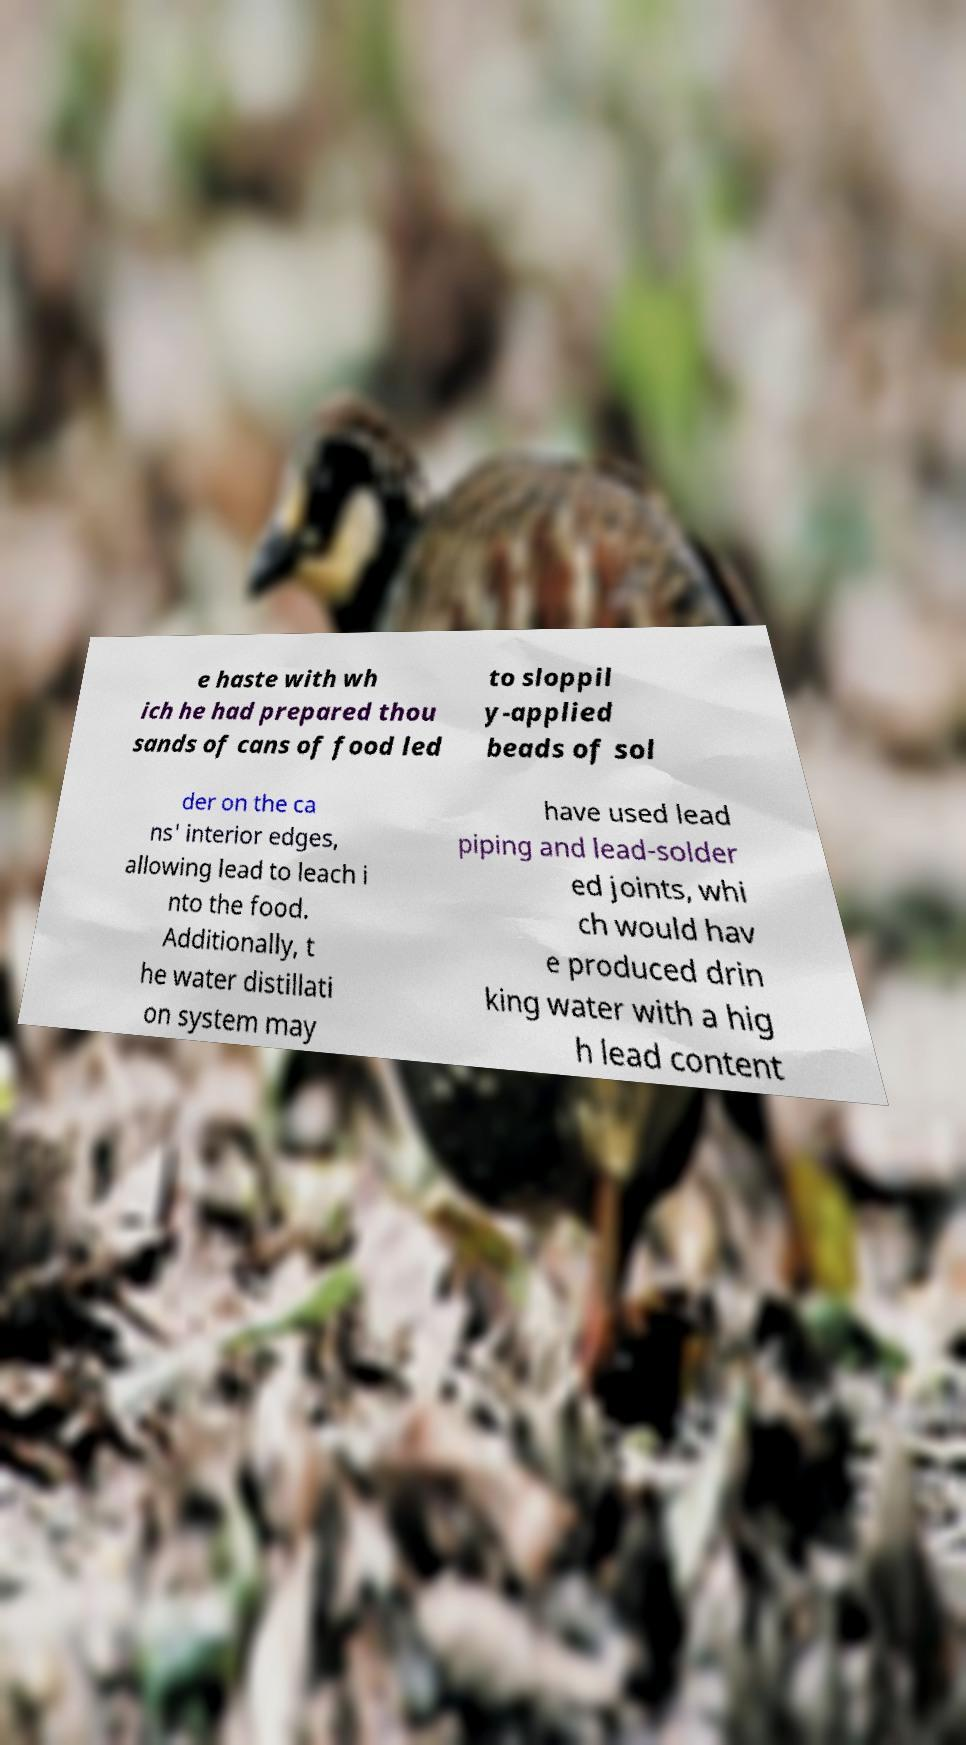What messages or text are displayed in this image? I need them in a readable, typed format. e haste with wh ich he had prepared thou sands of cans of food led to sloppil y-applied beads of sol der on the ca ns' interior edges, allowing lead to leach i nto the food. Additionally, t he water distillati on system may have used lead piping and lead-solder ed joints, whi ch would hav e produced drin king water with a hig h lead content 